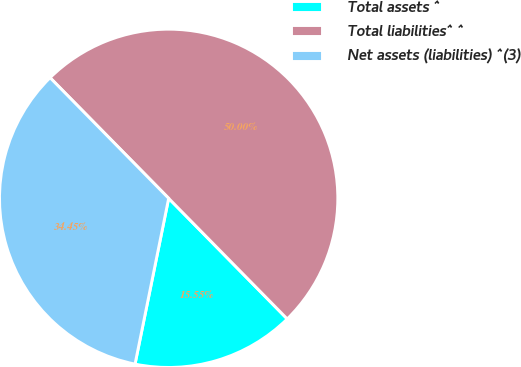Convert chart to OTSL. <chart><loc_0><loc_0><loc_500><loc_500><pie_chart><fcel>Total assets ^<fcel>Total liabilities^ ^<fcel>Net assets (liabilities) ^(3)<nl><fcel>15.55%<fcel>50.0%<fcel>34.45%<nl></chart> 